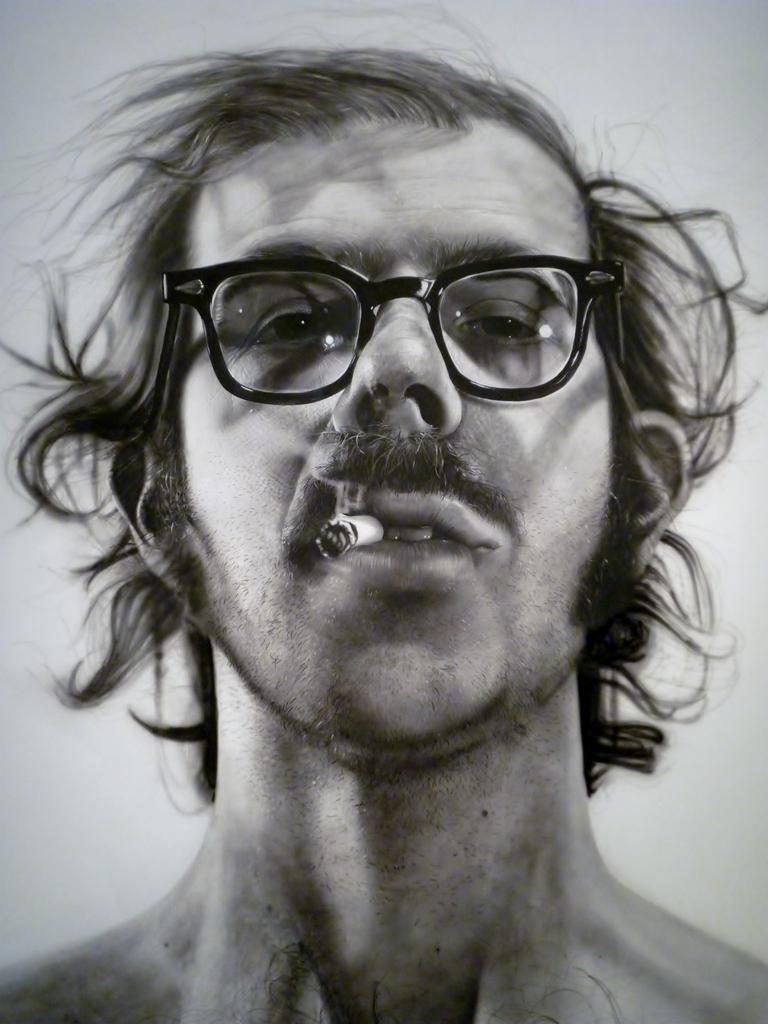What is the color scheme of the image? The image is black and white. Who is the main subject in the image? There is a man in the center of the image. What is the man doing in the image? The man is holding a cigarette in his mouth. What type of structure can be seen shaking due to an earthquake in the image? There is no structure or earthquake present in the image; it features a man holding a cigarette in his mouth. Can you describe the beetle crawling on the man's shoulder in the image? There is no beetle present on the man's shoulder in the image. 